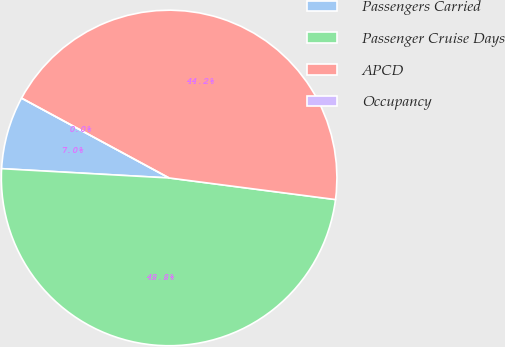Convert chart. <chart><loc_0><loc_0><loc_500><loc_500><pie_chart><fcel>Passengers Carried<fcel>Passenger Cruise Days<fcel>APCD<fcel>Occupancy<nl><fcel>7.01%<fcel>48.83%<fcel>44.16%<fcel>0.0%<nl></chart> 